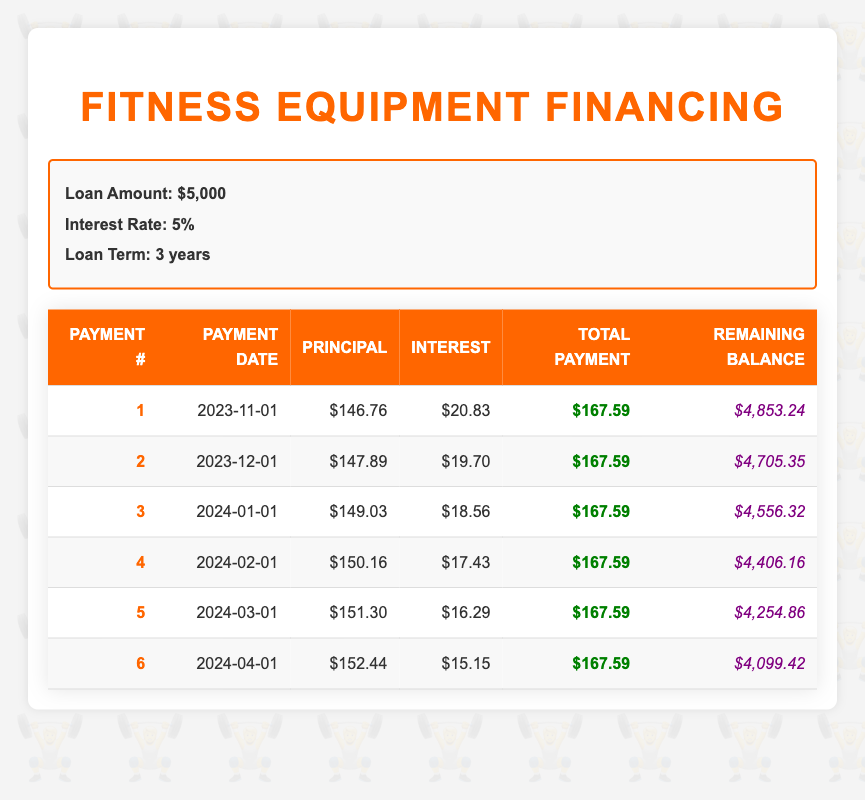What is the total amount paid after the first payment? The total payment for the first payment period is listed in the table as $167.59. Thus, after the first payment, the total amount paid is simply this value.
Answer: 167.59 What is the interest payment for the fourth month? Referring to the data in the fourth row, the interest payment for the fourth month is noted as $17.43.
Answer: 17.43 What is the average principal payment over the first six months? To find the average principal payment, sum the principal payments for the first six months: (146.76 + 147.89 + 149.03 + 150.16 + 151.30 + 152.44) = 897.58, then divide by 6 payments. 897.58 / 6 = 149.597, which rounds to 149.60.
Answer: 149.60 Is the principal payment increasing each month? Observing the principal payments across the first six months: 146.76, 147.89, 149.03, 150.16, 151.30, and 152.44 shows that each monthly payment amount is higher than the previous one, confirming that the principal payment is increasing.
Answer: Yes What will be the remaining balance after the third payment? The remaining balance after the third payment is provided in the table under the third payment, which is $4,556.32.
Answer: 4,556.32 What is the trend in the interest payments in the first six months? The interest payments for the first six months are $20.83, $19.70, $18.56, $17.43, $16.29, and $15.15. Observing these values shows a consistent decrease in interest payments each month, indicating a decreasing trend as more principal is repaid.
Answer: Decreasing trend 